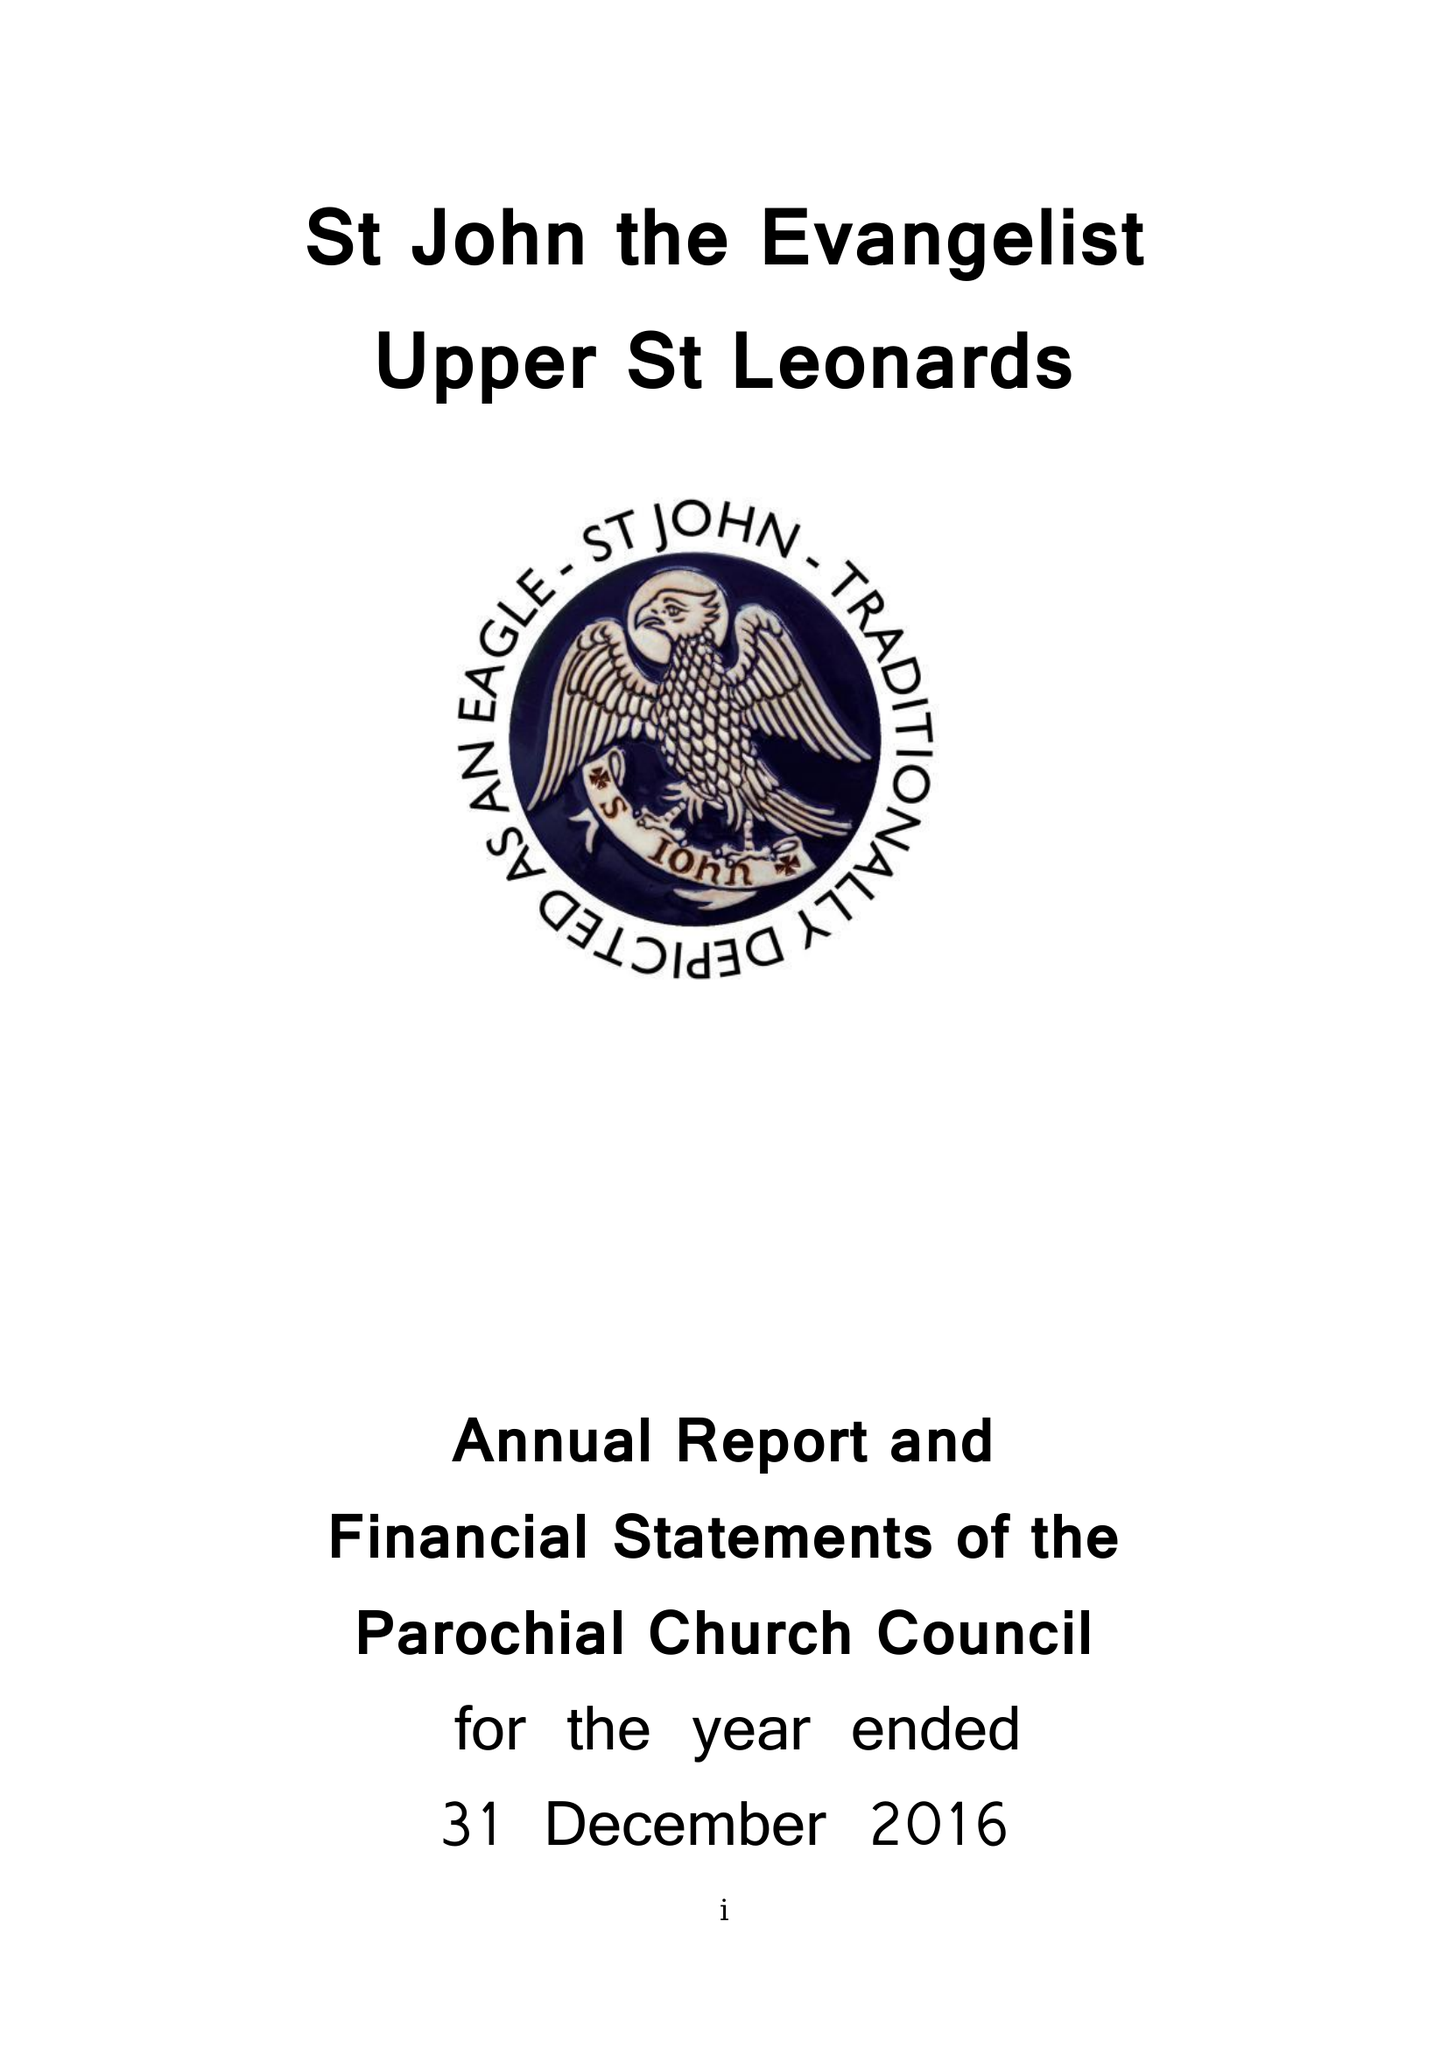What is the value for the address__post_town?
Answer the question using a single word or phrase. ST. LEONARDS-ON-SEA 